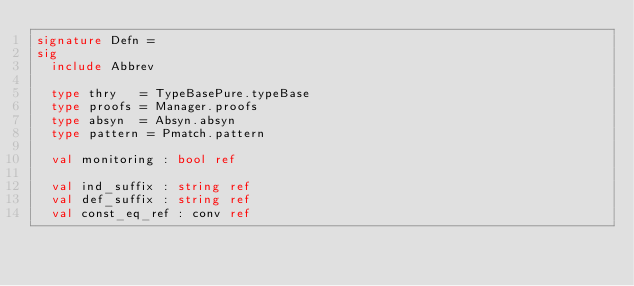<code> <loc_0><loc_0><loc_500><loc_500><_SML_>signature Defn =
sig
  include Abbrev

  type thry   = TypeBasePure.typeBase
  type proofs = Manager.proofs
  type absyn  = Absyn.absyn
  type pattern = Pmatch.pattern

  val monitoring : bool ref

  val ind_suffix : string ref
  val def_suffix : string ref
  val const_eq_ref : conv ref
</code> 